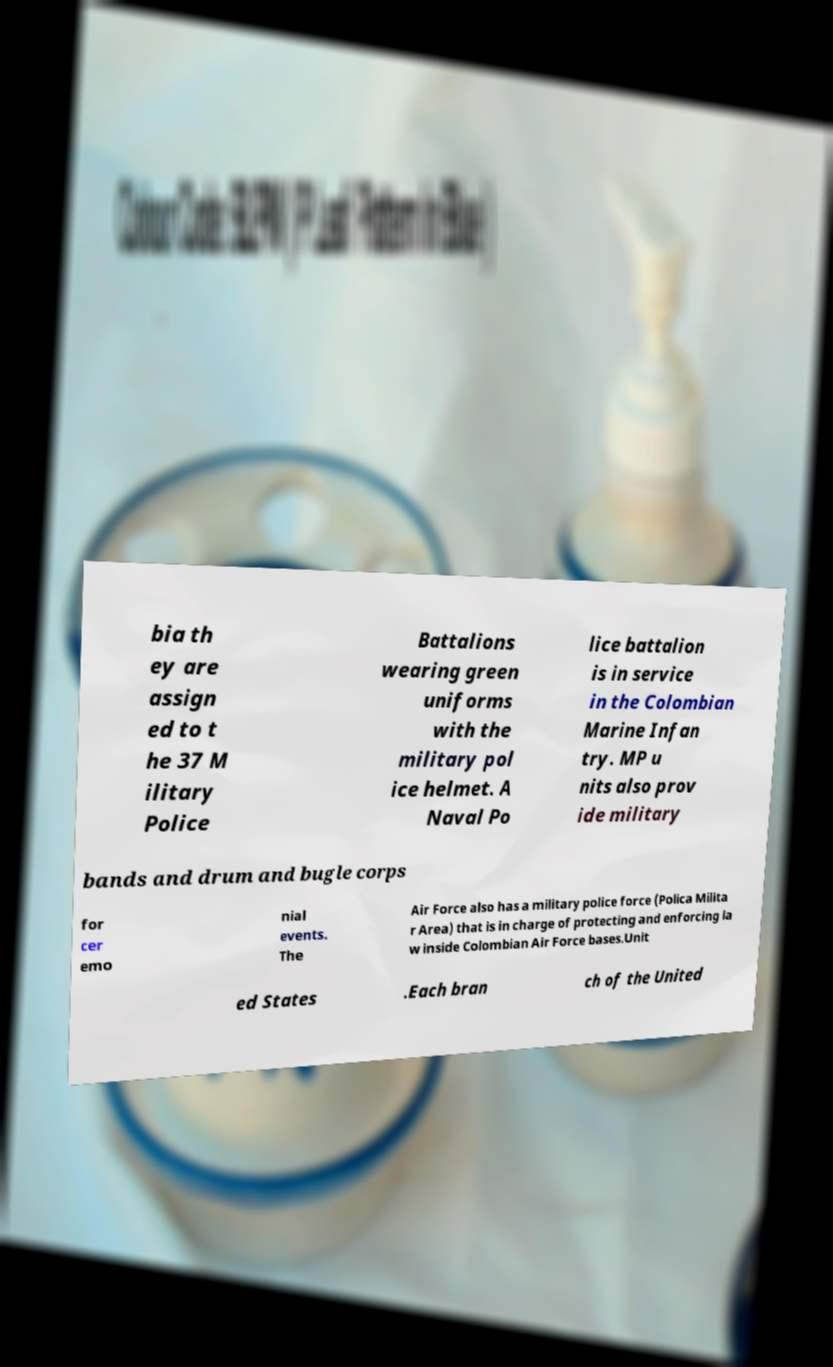There's text embedded in this image that I need extracted. Can you transcribe it verbatim? bia th ey are assign ed to t he 37 M ilitary Police Battalions wearing green uniforms with the military pol ice helmet. A Naval Po lice battalion is in service in the Colombian Marine Infan try. MP u nits also prov ide military bands and drum and bugle corps for cer emo nial events. The Air Force also has a military police force (Polica Milita r Area) that is in charge of protecting and enforcing la w inside Colombian Air Force bases.Unit ed States .Each bran ch of the United 